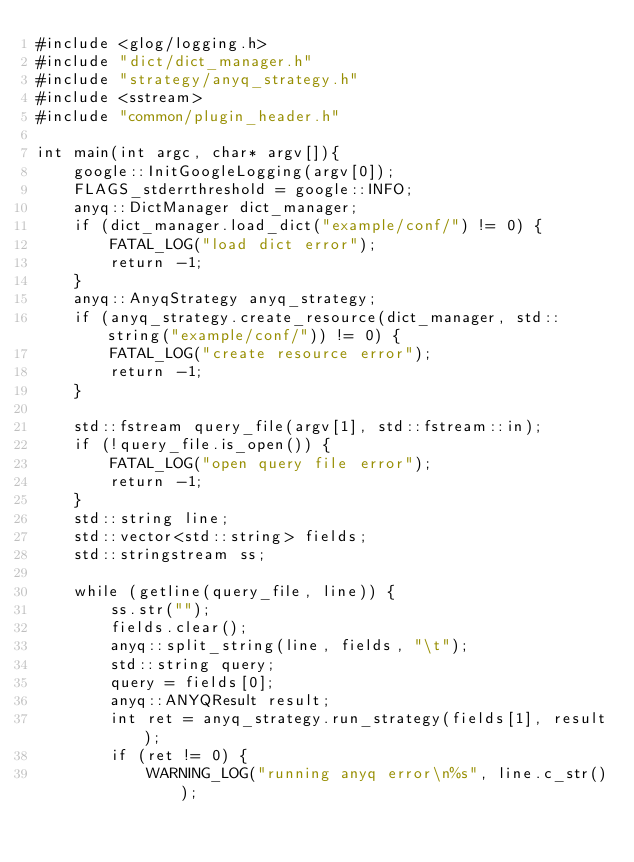<code> <loc_0><loc_0><loc_500><loc_500><_C++_>#include <glog/logging.h>
#include "dict/dict_manager.h"
#include "strategy/anyq_strategy.h"
#include <sstream>
#include "common/plugin_header.h"

int main(int argc, char* argv[]){
    google::InitGoogleLogging(argv[0]);
    FLAGS_stderrthreshold = google::INFO;
    anyq::DictManager dict_manager;
    if (dict_manager.load_dict("example/conf/") != 0) {
        FATAL_LOG("load dict error");
        return -1;
    }
    anyq::AnyqStrategy anyq_strategy;
    if (anyq_strategy.create_resource(dict_manager, std::string("example/conf/")) != 0) {
        FATAL_LOG("create resource error");
        return -1;
    }

    std::fstream query_file(argv[1], std::fstream::in);
    if (!query_file.is_open()) {
        FATAL_LOG("open query file error");
        return -1;
    }
    std::string line;
    std::vector<std::string> fields;
    std::stringstream ss;

    while (getline(query_file, line)) {
        ss.str("");
        fields.clear();
        anyq::split_string(line, fields, "\t");
        std::string query;
        query = fields[0];
        anyq::ANYQResult result;
        int ret = anyq_strategy.run_strategy(fields[1], result);
        if (ret != 0) {
            WARNING_LOG("running anyq error\n%s", line.c_str());</code> 